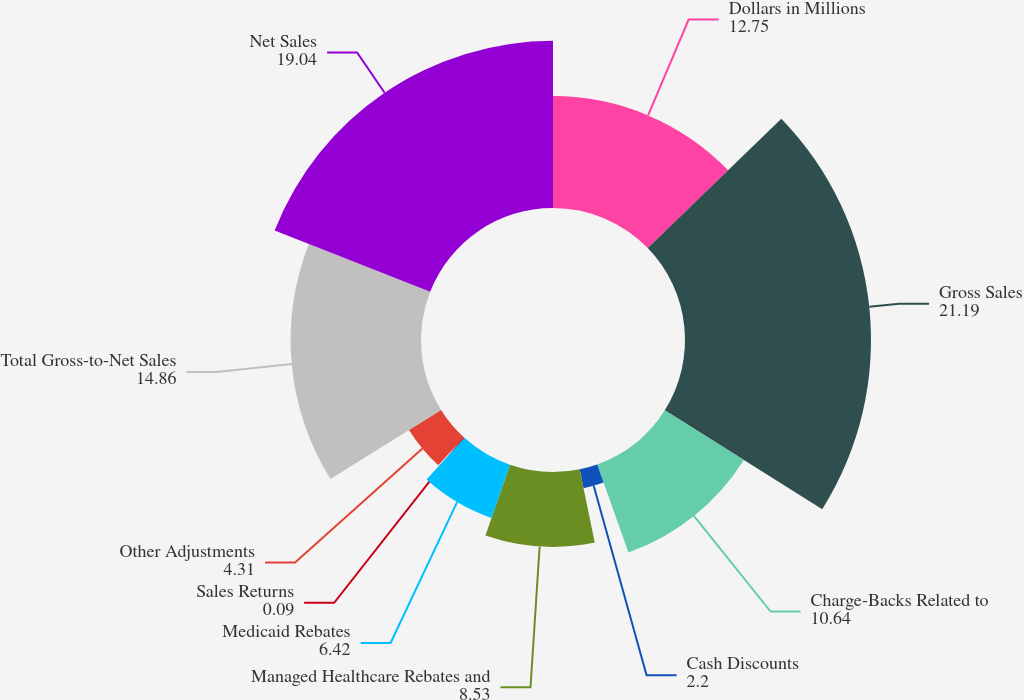<chart> <loc_0><loc_0><loc_500><loc_500><pie_chart><fcel>Dollars in Millions<fcel>Gross Sales<fcel>Charge-Backs Related to<fcel>Cash Discounts<fcel>Managed Healthcare Rebates and<fcel>Medicaid Rebates<fcel>Sales Returns<fcel>Other Adjustments<fcel>Total Gross-to-Net Sales<fcel>Net Sales<nl><fcel>12.75%<fcel>21.19%<fcel>10.64%<fcel>2.2%<fcel>8.53%<fcel>6.42%<fcel>0.09%<fcel>4.31%<fcel>14.86%<fcel>19.04%<nl></chart> 